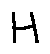Convert formula to latex. <formula><loc_0><loc_0><loc_500><loc_500>H</formula> 